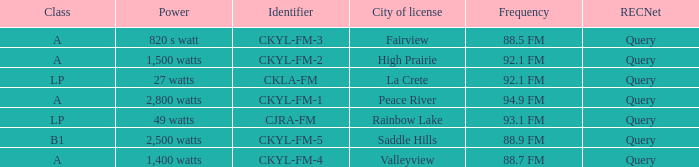What is the power with 88.5 fm frequency 820 s watt. 